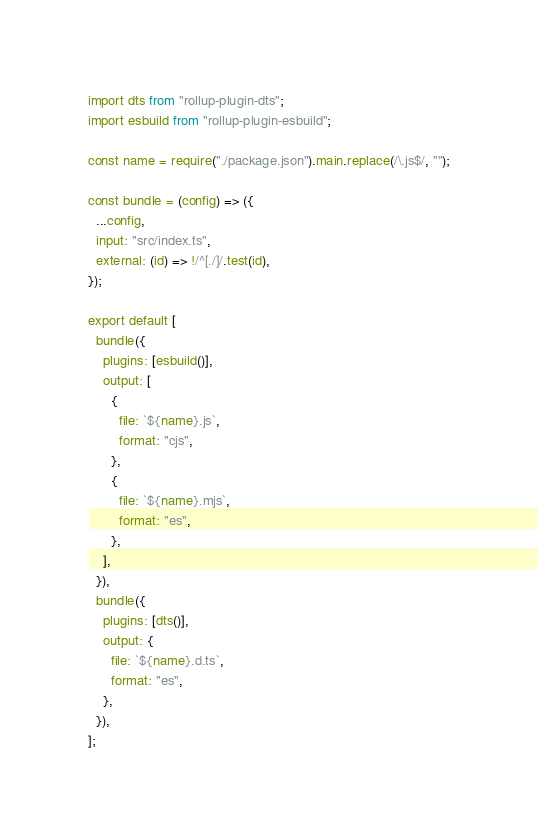Convert code to text. <code><loc_0><loc_0><loc_500><loc_500><_JavaScript_>import dts from "rollup-plugin-dts";
import esbuild from "rollup-plugin-esbuild";

const name = require("./package.json").main.replace(/\.js$/, "");

const bundle = (config) => ({
  ...config,
  input: "src/index.ts",
  external: (id) => !/^[./]/.test(id),
});

export default [
  bundle({
    plugins: [esbuild()],
    output: [
      {
        file: `${name}.js`,
        format: "cjs",
      },
      {
        file: `${name}.mjs`,
        format: "es",
      },
    ],
  }),
  bundle({
    plugins: [dts()],
    output: {
      file: `${name}.d.ts`,
      format: "es",
    },
  }),
];
</code> 